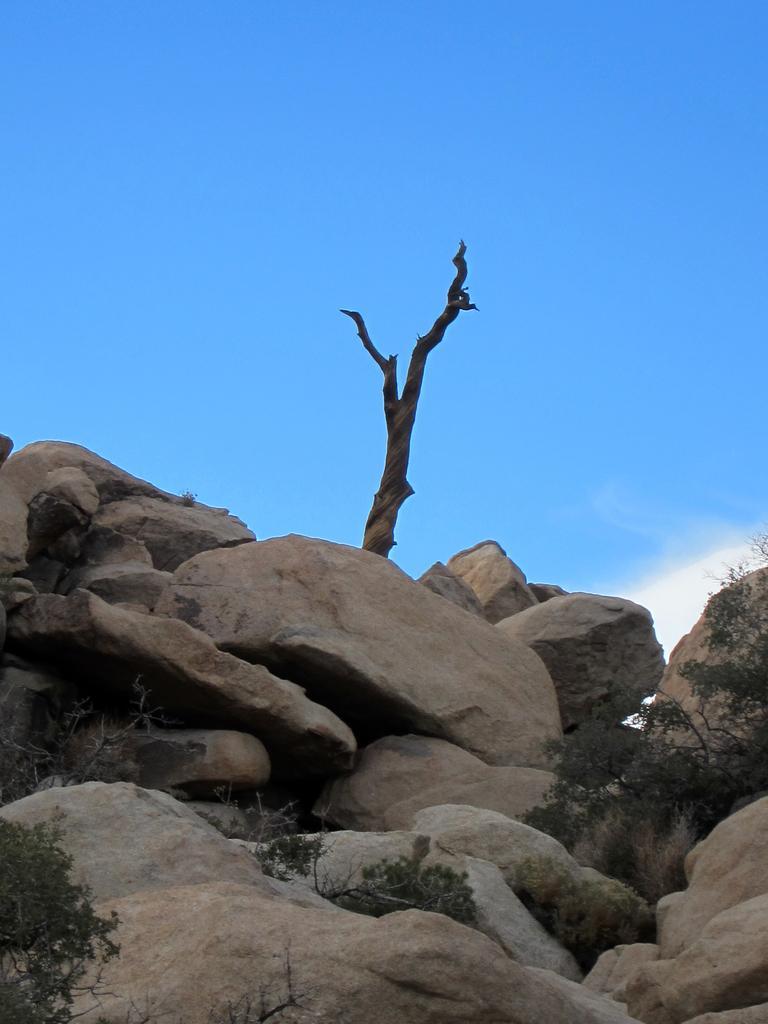How would you summarize this image in a sentence or two? In the middle of the image we can see some rocks and trees. At the top of the image there are some clouds in the sky. 